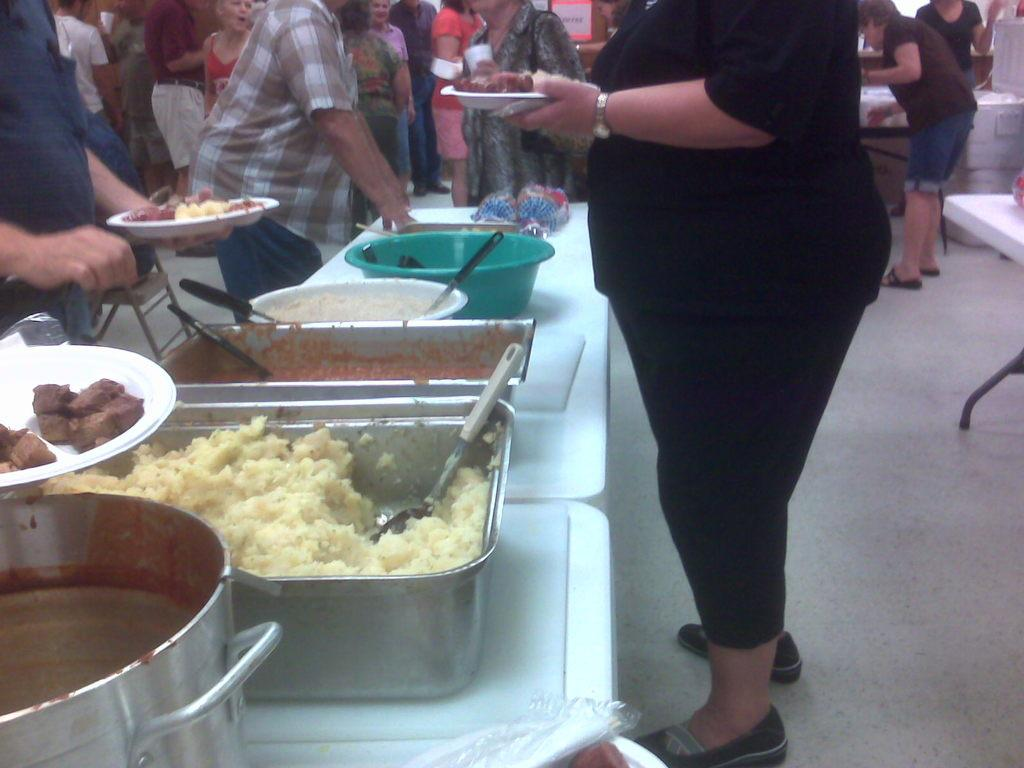What type of setting is shown in the image? The image depicts a buffet. What are the people in the image doing? People are serving food at the buffet. Where is the food located in the image? The food is kept on a table. Who is serving the food in the image? There are women behind the table serving the food. What type of boundary can be seen surrounding the buffet in the image? There is no boundary surrounding the buffet in the image. Can you tell me the name of the brother of the woman serving food in the image? There is no information about the woman's brother in the image. 